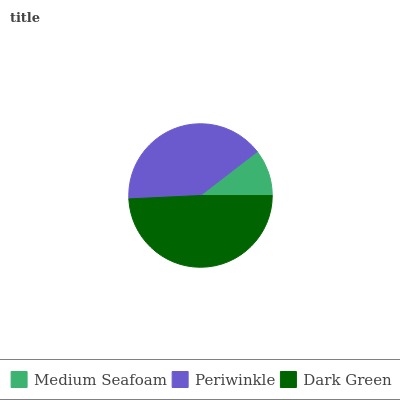Is Medium Seafoam the minimum?
Answer yes or no. Yes. Is Dark Green the maximum?
Answer yes or no. Yes. Is Periwinkle the minimum?
Answer yes or no. No. Is Periwinkle the maximum?
Answer yes or no. No. Is Periwinkle greater than Medium Seafoam?
Answer yes or no. Yes. Is Medium Seafoam less than Periwinkle?
Answer yes or no. Yes. Is Medium Seafoam greater than Periwinkle?
Answer yes or no. No. Is Periwinkle less than Medium Seafoam?
Answer yes or no. No. Is Periwinkle the high median?
Answer yes or no. Yes. Is Periwinkle the low median?
Answer yes or no. Yes. Is Dark Green the high median?
Answer yes or no. No. Is Medium Seafoam the low median?
Answer yes or no. No. 